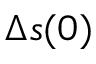<formula> <loc_0><loc_0><loc_500><loc_500>\Delta s ( 0 )</formula> 